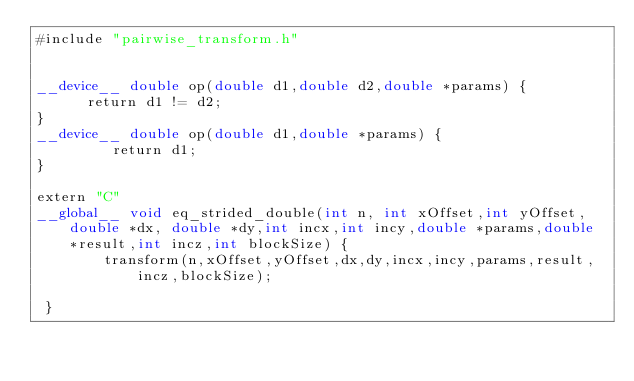Convert code to text. <code><loc_0><loc_0><loc_500><loc_500><_Cuda_>#include "pairwise_transform.h"


__device__ double op(double d1,double d2,double *params) {
      return d1 != d2;
}
__device__ double op(double d1,double *params) {
         return d1;
}

extern "C"
__global__ void eq_strided_double(int n, int xOffset,int yOffset,double *dx, double *dy,int incx,int incy,double *params,double *result,int incz,int blockSize) {
        transform(n,xOffset,yOffset,dx,dy,incx,incy,params,result,incz,blockSize);

 }


</code> 